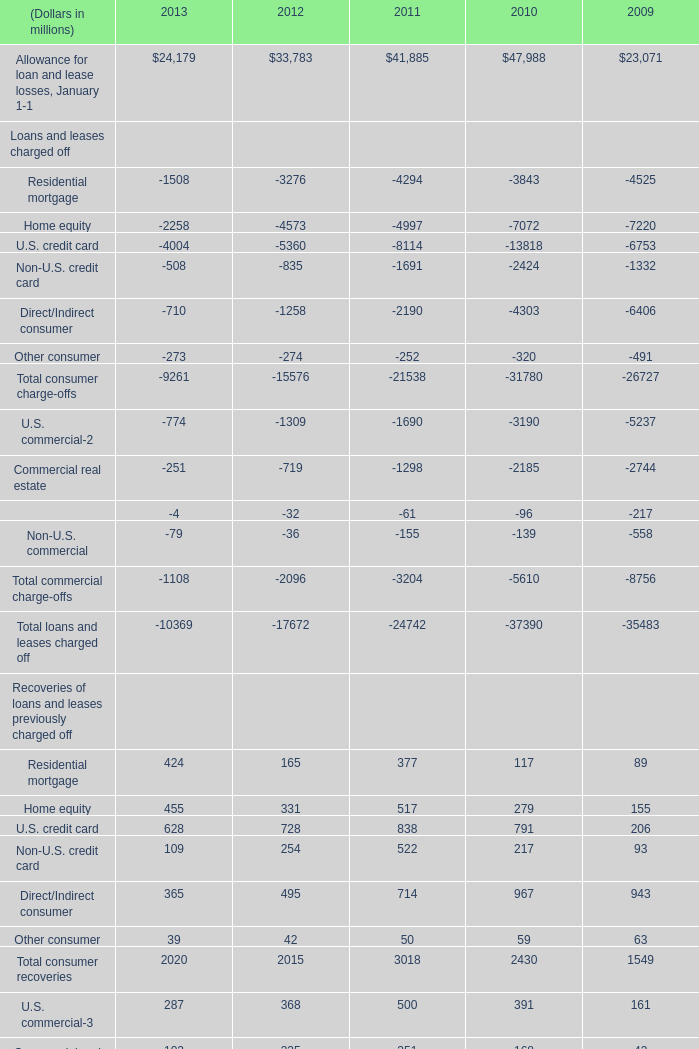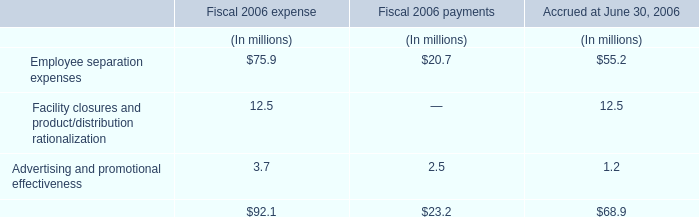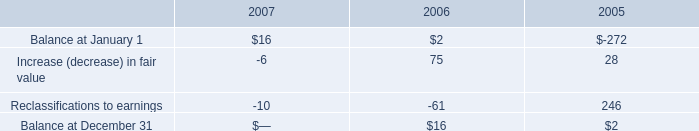What's the average of Residential mortgage and Home equity in Recoveries of loans and leases previously charged off in 2013? (in millions) 
Computations: ((424 + 455) / 2)
Answer: 439.5. 